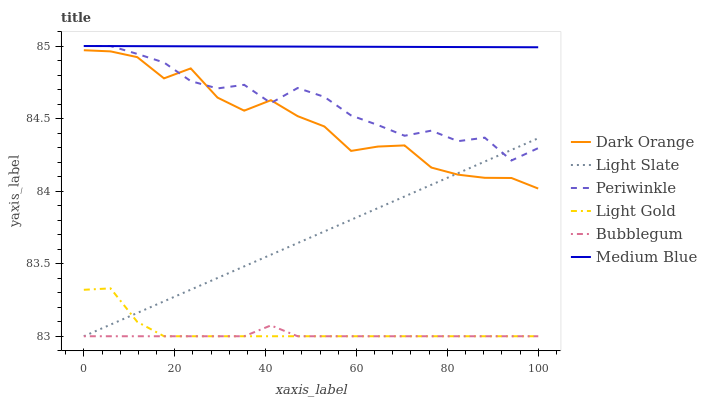Does Bubblegum have the minimum area under the curve?
Answer yes or no. Yes. Does Medium Blue have the maximum area under the curve?
Answer yes or no. Yes. Does Light Slate have the minimum area under the curve?
Answer yes or no. No. Does Light Slate have the maximum area under the curve?
Answer yes or no. No. Is Medium Blue the smoothest?
Answer yes or no. Yes. Is Dark Orange the roughest?
Answer yes or no. Yes. Is Light Slate the smoothest?
Answer yes or no. No. Is Light Slate the roughest?
Answer yes or no. No. Does Light Slate have the lowest value?
Answer yes or no. Yes. Does Medium Blue have the lowest value?
Answer yes or no. No. Does Periwinkle have the highest value?
Answer yes or no. Yes. Does Light Slate have the highest value?
Answer yes or no. No. Is Bubblegum less than Periwinkle?
Answer yes or no. Yes. Is Dark Orange greater than Light Gold?
Answer yes or no. Yes. Does Periwinkle intersect Medium Blue?
Answer yes or no. Yes. Is Periwinkle less than Medium Blue?
Answer yes or no. No. Is Periwinkle greater than Medium Blue?
Answer yes or no. No. Does Bubblegum intersect Periwinkle?
Answer yes or no. No. 